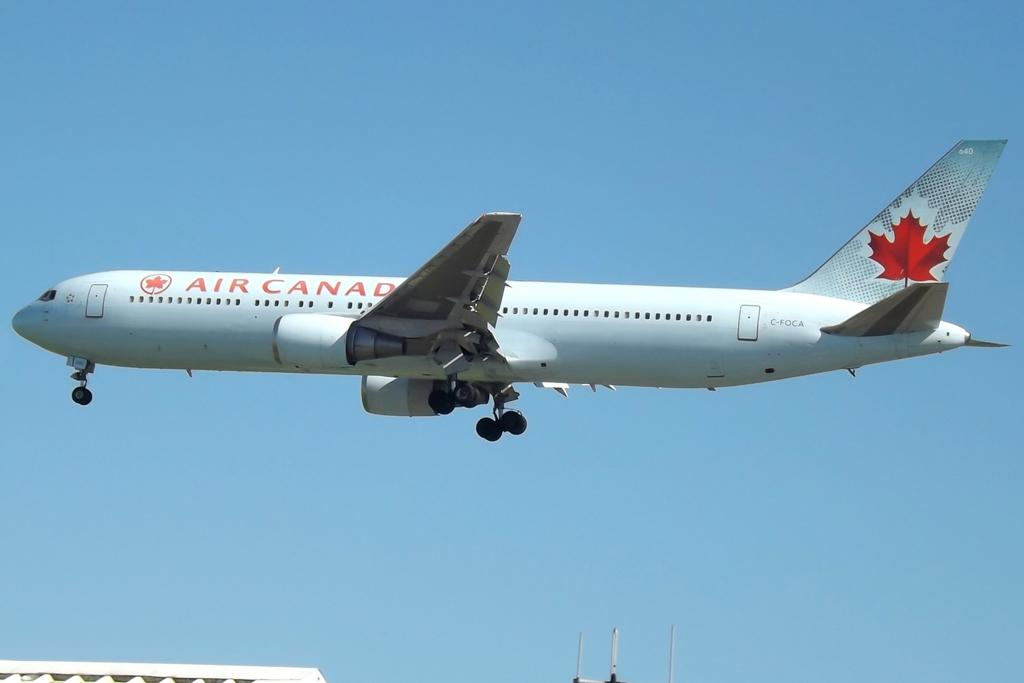<image>
Present a compact description of the photo's key features. An Air Canada airplane just taking off from the tarmac. 